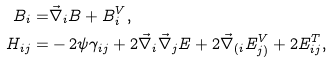Convert formula to latex. <formula><loc_0><loc_0><loc_500><loc_500>B _ { i } = & \vec { \nabla } _ { i } B + B ^ { V } _ { i } , \\ H _ { i j } = & - 2 \psi \gamma _ { i j } + 2 \vec { \nabla } _ { i } \vec { \nabla } _ { j } E + 2 \vec { \nabla } _ { ( i } E ^ { V } _ { j ) } + 2 { E } ^ { T } _ { i j } ,</formula> 